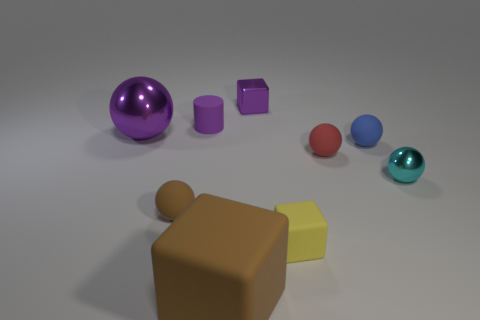Subtract all purple cubes. How many cubes are left? 2 Subtract all large spheres. How many spheres are left? 4 Add 4 tiny yellow rubber cubes. How many tiny yellow rubber cubes exist? 5 Subtract 0 gray cubes. How many objects are left? 9 Subtract all blocks. How many objects are left? 6 Subtract 1 blocks. How many blocks are left? 2 Subtract all brown cubes. Subtract all gray cylinders. How many cubes are left? 2 Subtract all brown blocks. How many blue spheres are left? 1 Subtract all purple blocks. Subtract all metal cubes. How many objects are left? 7 Add 5 brown matte objects. How many brown matte objects are left? 7 